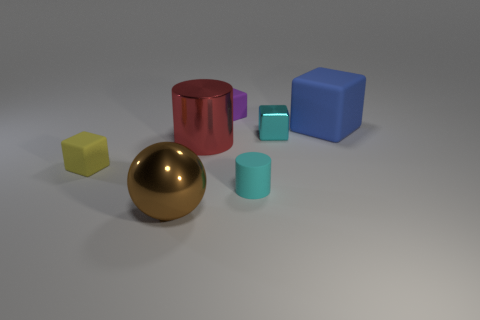Subtract 1 blocks. How many blocks are left? 3 Add 2 cyan cylinders. How many objects exist? 9 Subtract all spheres. How many objects are left? 6 Add 1 spheres. How many spheres are left? 2 Add 5 big purple matte balls. How many big purple matte balls exist? 5 Subtract 1 yellow blocks. How many objects are left? 6 Subtract all gray metallic spheres. Subtract all blocks. How many objects are left? 3 